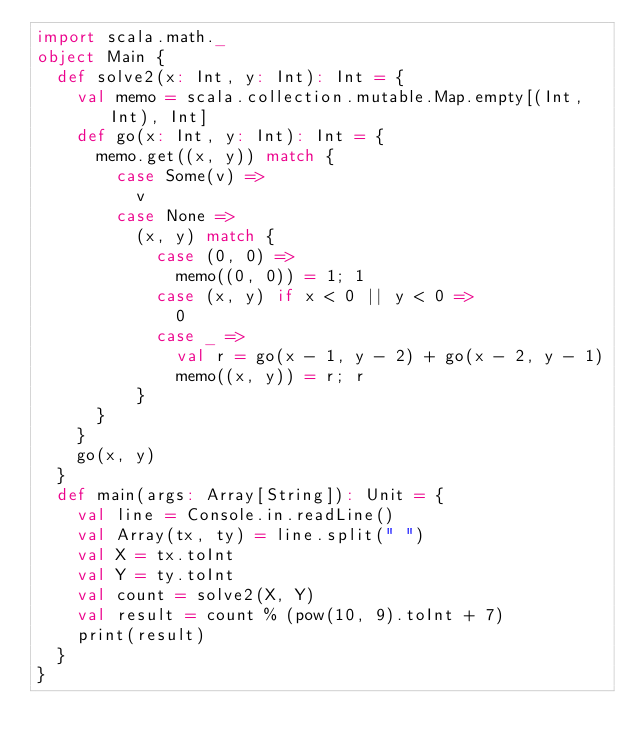<code> <loc_0><loc_0><loc_500><loc_500><_Scala_>import scala.math._
object Main {
  def solve2(x: Int, y: Int): Int = {
    val memo = scala.collection.mutable.Map.empty[(Int, Int), Int]
    def go(x: Int, y: Int): Int = {
      memo.get((x, y)) match {
        case Some(v) =>
          v
        case None =>
          (x, y) match {
            case (0, 0) =>
              memo((0, 0)) = 1; 1
            case (x, y) if x < 0 || y < 0 =>
              0
            case _ =>
              val r = go(x - 1, y - 2) + go(x - 2, y - 1)
              memo((x, y)) = r; r
          }
      }
    }
    go(x, y)
  }
  def main(args: Array[String]): Unit = {
    val line = Console.in.readLine()
    val Array(tx, ty) = line.split(" ")
    val X = tx.toInt
    val Y = ty.toInt
    val count = solve2(X, Y)
    val result = count % (pow(10, 9).toInt + 7)
    print(result)
  }
}</code> 